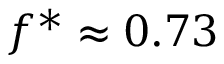Convert formula to latex. <formula><loc_0><loc_0><loc_500><loc_500>f ^ { * } \approx 0 . 7 3</formula> 